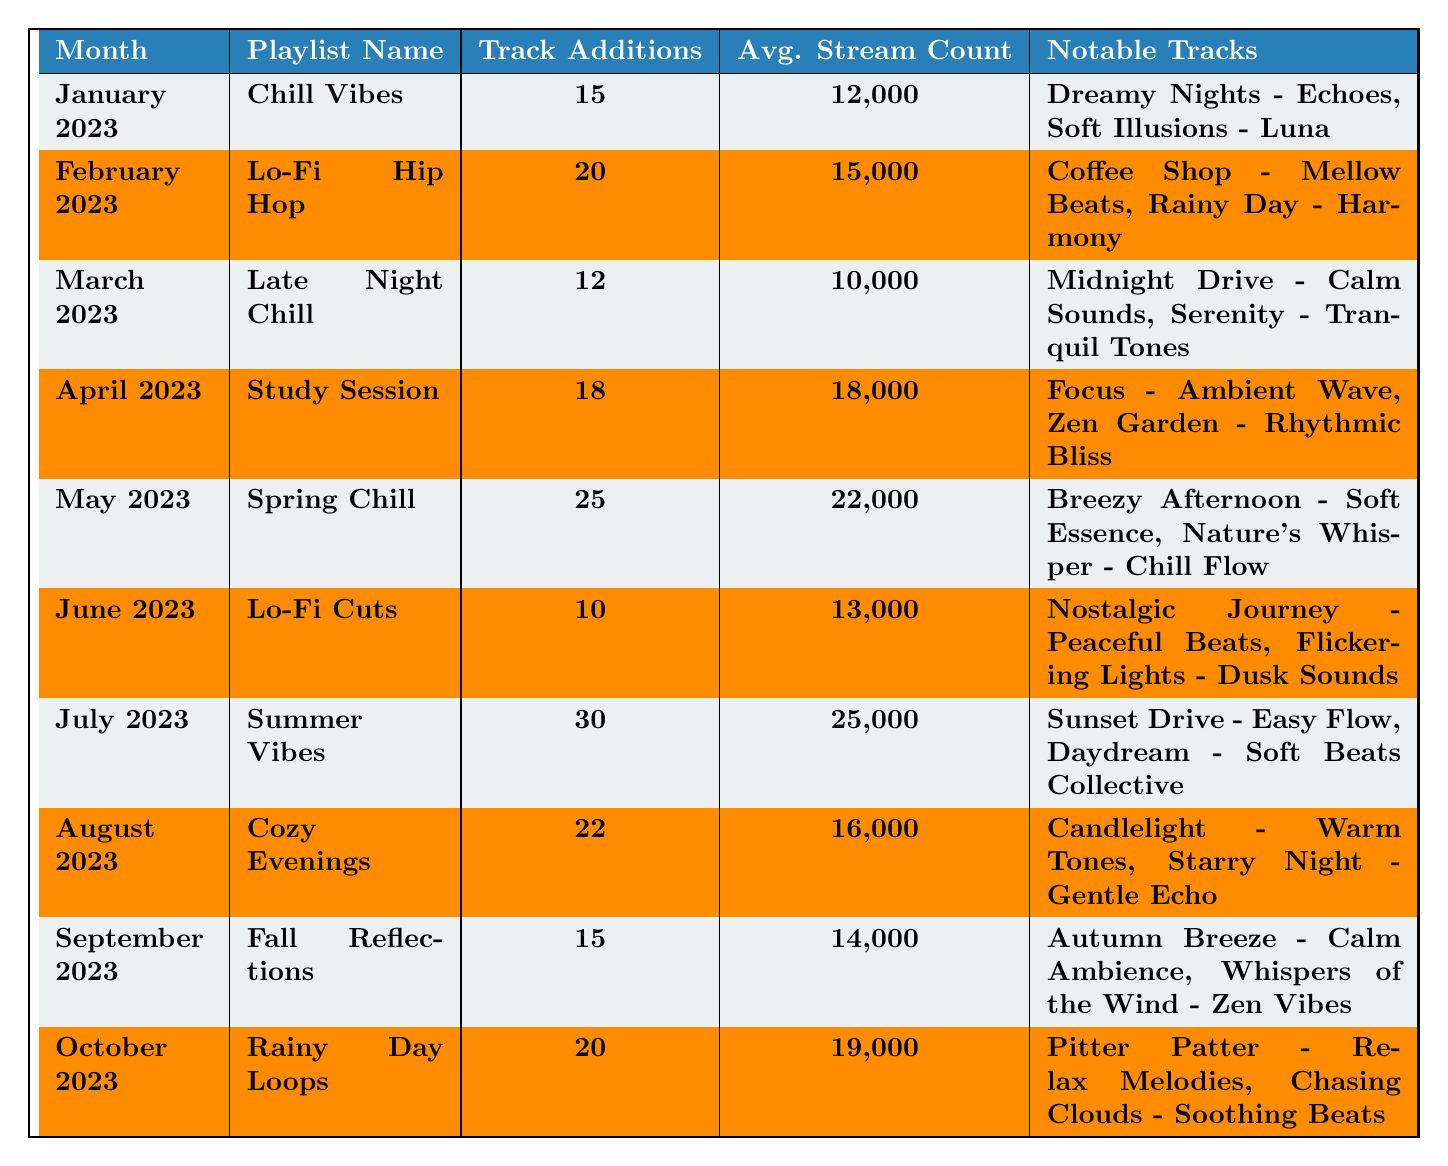What is the highest average stream count for a playlist? From the table, check each row for the average stream count. The maximum value is found in July 2023 with 25,000 streams.
Answer: 25,000 How many tracks were added to the "Lo-Fi Hip Hop" playlist? Locate the row for "Lo-Fi Hip Hop" in February 2023 and check the "Track Additions" column, which shows 20.
Answer: 20 Which month had the fewest track additions? Review the "Track Additions" column to see the counts for each month. The lowest count is 10 in June 2023.
Answer: June 2023 What is the average stream count for playlists added in the first half of the year (January to June)? Add the average stream counts for January (12,000), February (15,000), March (10,000), April (18,000), May (22,000), and June (13,000). The total is 90,000 and dividing by 6 gives 15,000.
Answer: 15,000 Did the average stream counts increase, decrease, or remain the same from April to July? Compare the averages for April (18,000) and July (25,000). Since 25,000 is greater than 18,000, it indicates an increase.
Answer: Increase What is the difference in average stream counts between "Spring Chill" and "Late Night Chill"? Subtract the average stream count of "Late Night Chill" (10,000) from "Spring Chill" (22,000), resulting in a difference of 12,000.
Answer: 12,000 Which playlist had the most notable tracks, and how many were there? Review the "Notable Tracks" column for each playlist. May 2023's "Spring Chill" and July 2023's "Summer Vibes" both have 2 notable tracks but check the title importance or flow.
Answer: Spring Chill and Summer Vibes; 2 tracks each Is it true that all months of 2023 had at least 10 track additions? Check the "Track Additions" column for all months. The lowest is June with 10 track additions, confirming all had at least 10.
Answer: Yes For which playlist was the average stream count closest to 14,000? Examine the average stream counts. "Fall Reflections" (14,000) matches this exactly, and "Cozy Evenings" (16,000) is the closest next.
Answer: Fall Reflections What was the total number of tracks added from January to March? Add the track additions for January (15), February (20), and March (12). The total is 47 tracks.
Answer: 47 